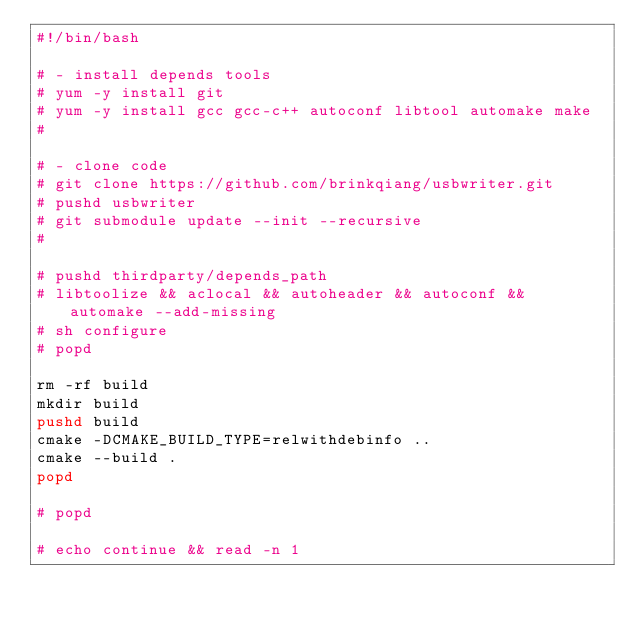Convert code to text. <code><loc_0><loc_0><loc_500><loc_500><_Bash_>#!/bin/bash

# - install depends tools
# yum -y install git
# yum -y install gcc gcc-c++ autoconf libtool automake make
#

# - clone code
# git clone https://github.com/brinkqiang/usbwriter.git
# pushd usbwriter
# git submodule update --init --recursive
#

# pushd thirdparty/depends_path
# libtoolize && aclocal && autoheader && autoconf && automake --add-missing
# sh configure
# popd

rm -rf build
mkdir build
pushd build
cmake -DCMAKE_BUILD_TYPE=relwithdebinfo ..
cmake --build .
popd

# popd

# echo continue && read -n 1
</code> 